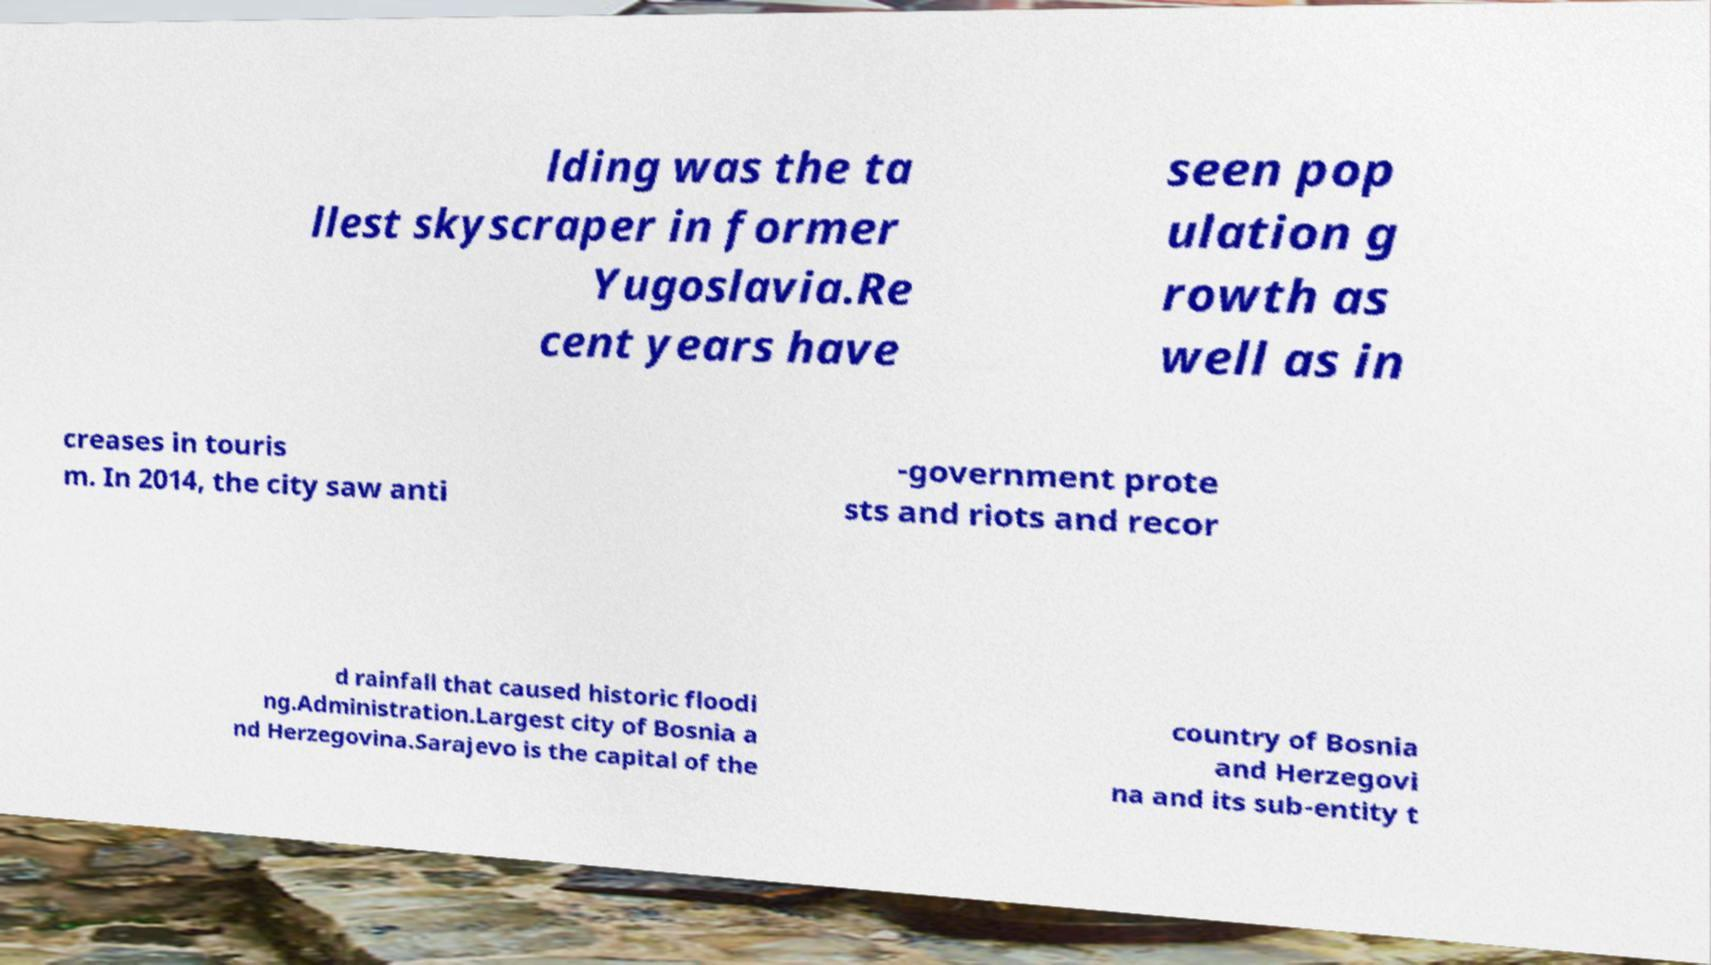Can you read and provide the text displayed in the image?This photo seems to have some interesting text. Can you extract and type it out for me? lding was the ta llest skyscraper in former Yugoslavia.Re cent years have seen pop ulation g rowth as well as in creases in touris m. In 2014, the city saw anti -government prote sts and riots and recor d rainfall that caused historic floodi ng.Administration.Largest city of Bosnia a nd Herzegovina.Sarajevo is the capital of the country of Bosnia and Herzegovi na and its sub-entity t 